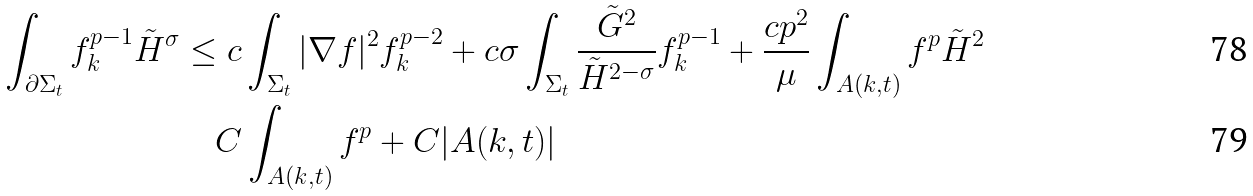<formula> <loc_0><loc_0><loc_500><loc_500>\int _ { \partial \Sigma _ { t } } f ^ { p - 1 } _ { k } \tilde { H } ^ { \sigma } & \leq c \int _ { \Sigma _ { t } } | \nabla f | ^ { 2 } f _ { k } ^ { p - 2 } + c \sigma \int _ { \Sigma _ { t } } \frac { \tilde { G } ^ { 2 } } { \tilde { H } ^ { 2 - \sigma } } f _ { k } ^ { p - 1 } + \frac { c p ^ { 2 } } { \mu } \int _ { A ( k , t ) } f ^ { p } \tilde { H } ^ { 2 } \\ & \quad C \int _ { A ( k , t ) } f ^ { p } + C | A ( k , t ) |</formula> 